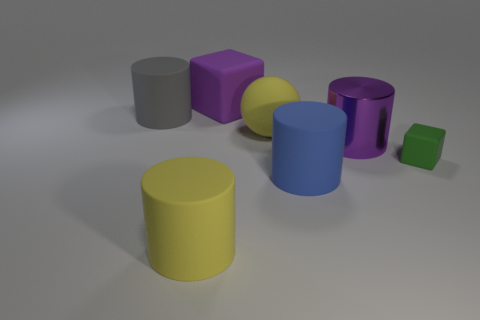What shape is the gray matte object that is the same size as the yellow rubber cylinder?
Offer a very short reply. Cylinder. Are there more tiny green balls than big yellow matte cylinders?
Offer a very short reply. No. Is there a large blue rubber cylinder that is behind the large shiny cylinder that is in front of the rubber ball?
Make the answer very short. No. What is the color of the other matte thing that is the same shape as the tiny green matte object?
Provide a short and direct response. Purple. Are there any other things that have the same shape as the small green rubber thing?
Give a very brief answer. Yes. There is a ball that is made of the same material as the big purple block; what color is it?
Provide a short and direct response. Yellow. Is there a yellow cylinder behind the large purple thing that is to the left of the large yellow sphere on the right side of the purple matte object?
Provide a short and direct response. No. Are there fewer big yellow cylinders that are behind the large metallic cylinder than green matte things that are to the left of the yellow cylinder?
Give a very brief answer. No. What number of small green objects are the same material as the yellow ball?
Ensure brevity in your answer.  1. There is a yellow matte cylinder; does it have the same size as the green thing right of the big blue object?
Make the answer very short. No. 